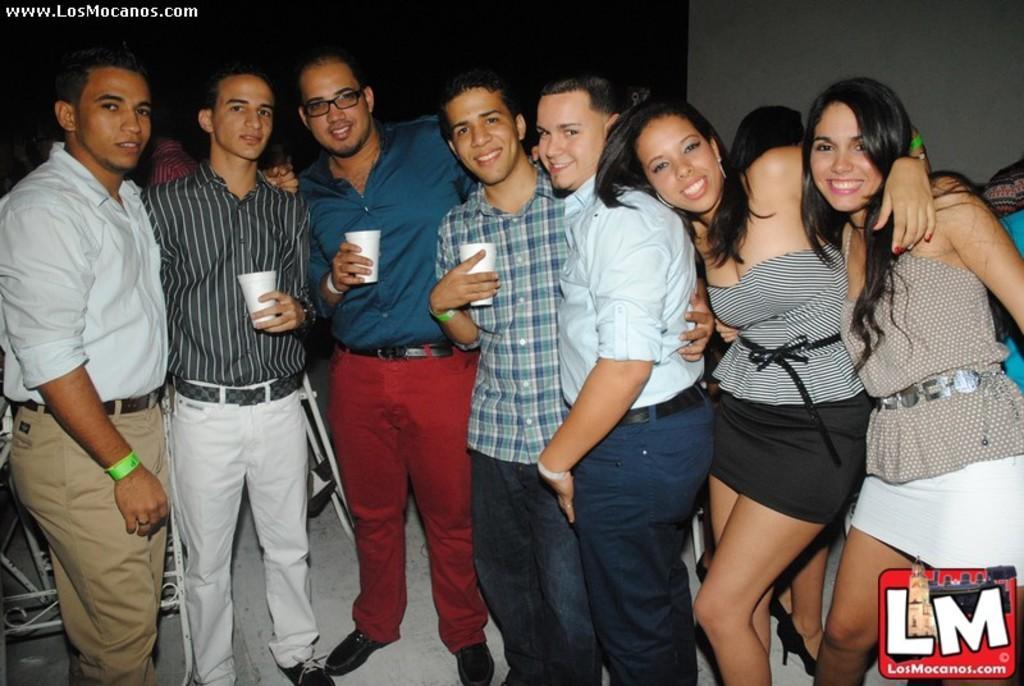Can you describe this image briefly? In this image I can see group of people standing. In front the person is holding a glass and the person is wearing green and blue color shirt and black color pant. Background the wall is white color. 